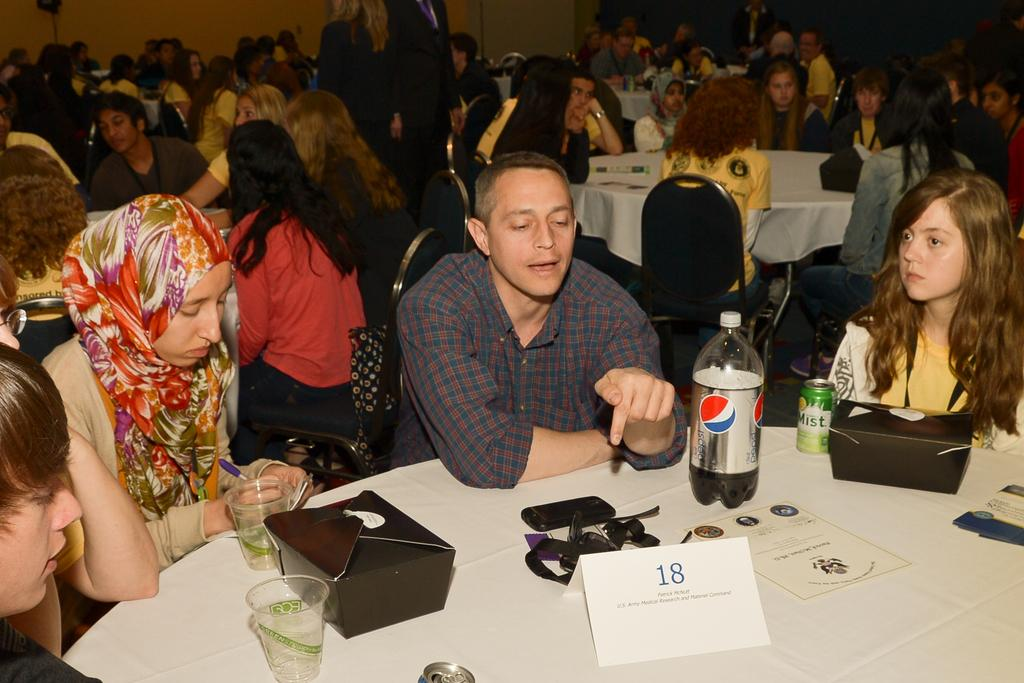What are the people in the image doing? The people in the image are sitting. What objects can be seen on the tables in the image? There is a bottle, glasses, a tin, papers, and boxes on the tables in the image. What is the background of the image? There is a wall in the background of the image. What color is the brain on the table in the image? There is no brain present on the table in the image. What type of business is being conducted in the image? The image does not depict any business activities; it only shows people sitting and objects on tables. 